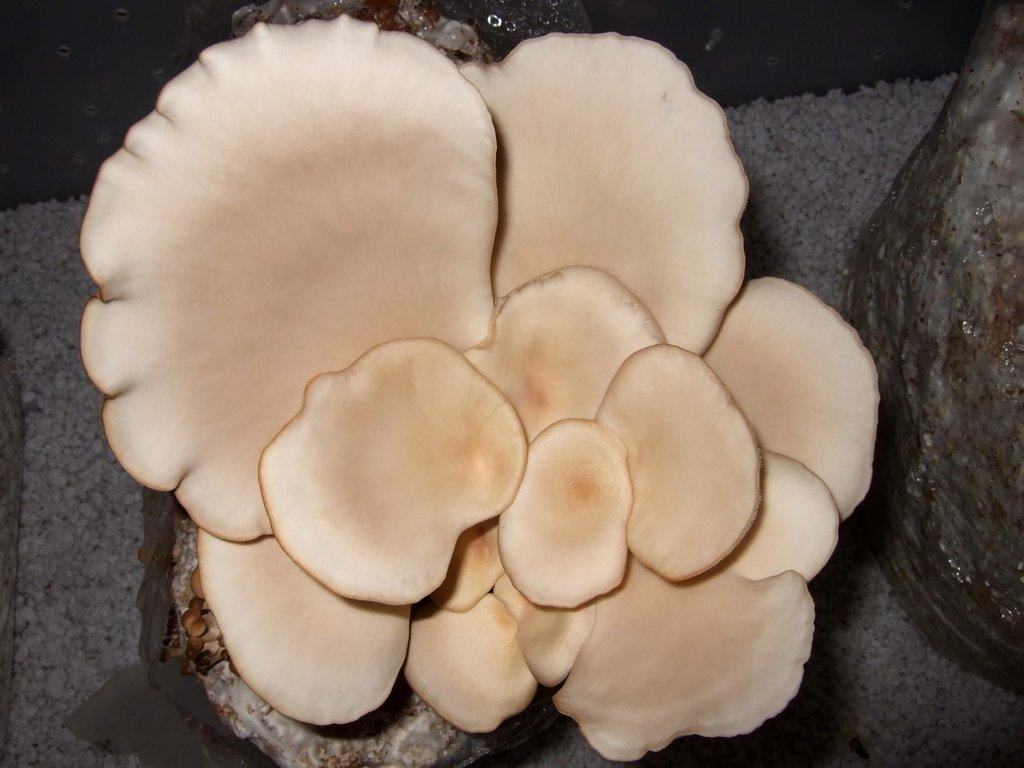What is located in the middle of the image? There are mushrooms in the middle of the image. What type of transport is visible in the image? There is no transport visible in the image; it only features mushrooms. What operation is being performed on the mushrooms in the image? There is no operation being performed on the mushrooms in the image; they are simply present. 